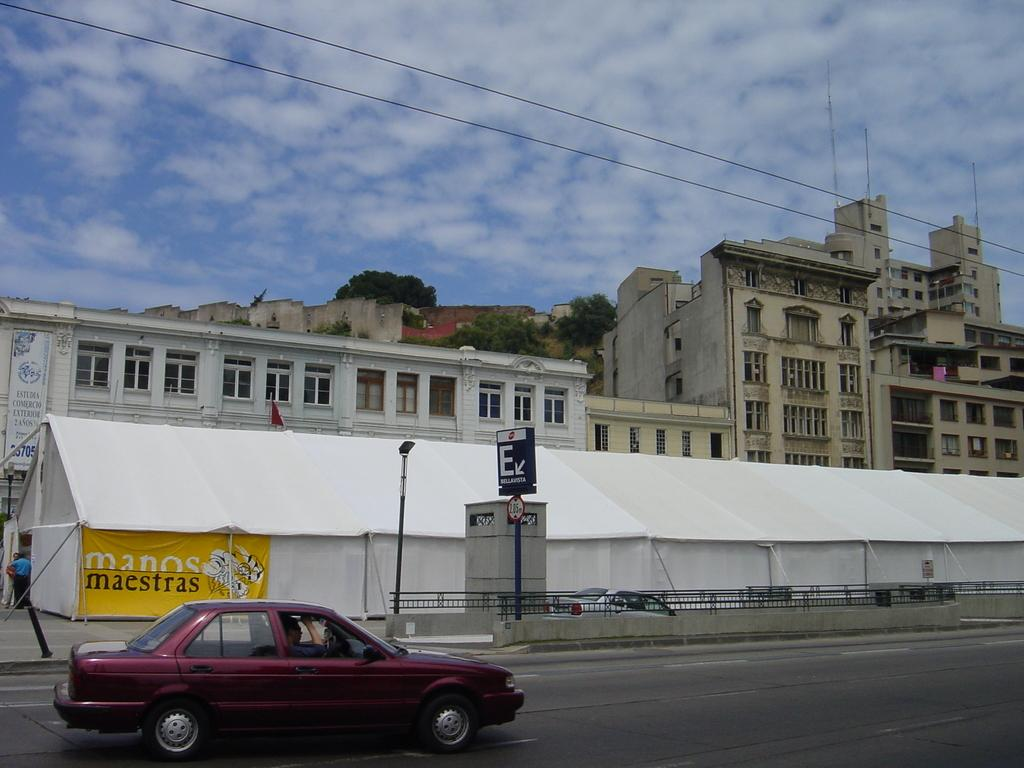What color is the car in the image? The car in the image is red. What is the car doing in the image? The car is moving on a road. What else can be seen in the image besides the car? There are white color tents visible in the image. What is visible in the background of the image? There are buildings in the background of the image. What is visible in the sky in the image? The sky is visible in the image, and clouds are present. Can you see the face of the driver in the car? There is no face visible in the image, as it only shows the car moving on a road. What type of rock can be seen in the image? There is no rock present in the image; it features a red car moving on a road, white tents, buildings, sky, and clouds. 